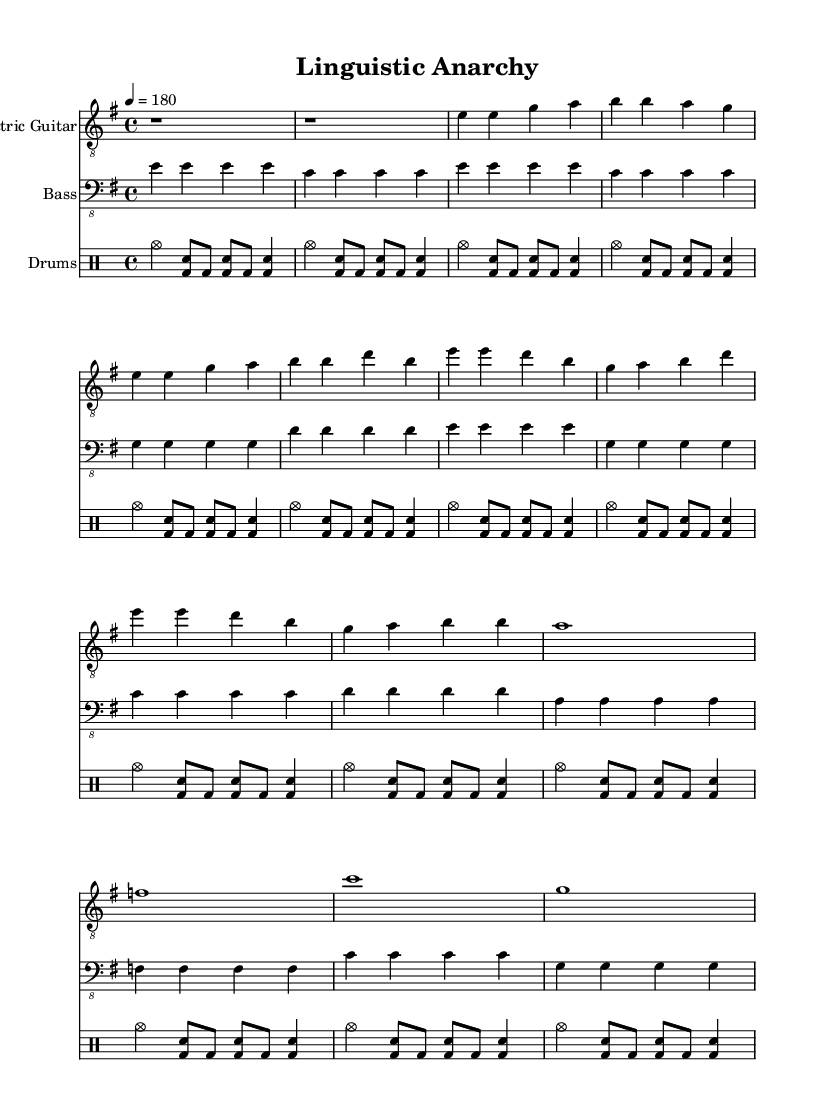What is the key signature of this music? The key signature is E minor, which has one sharp (F#).
Answer: E minor What is the time signature of the music? The time signature is 4/4, indicating four beats per measure.
Answer: 4/4 What is the tempo marking of the piece? The tempo marking is quarter note equals 180 beats per minute.
Answer: 180 How many measures are in the bridge section? The bridge section contains four measures, as indicated by the notations and spacing.
Answer: 4 What instrument is primarily driving the rhythm in this piece? The drums are primarily driving the rhythm, indicated by the use of the drummode and consistent patterns.
Answer: Drums In which section do you first encounter a full chord on a downbeat? The first full chord on a downbeat is encountered in the bridge section, specifically on the first beat of each measure.
Answer: Bridge What repetitive structure is notable in the verse and chorus sections? Both the verse and chorus sections have a repetitive structure with similar rhythmic patterns and chord progressions.
Answer: Repetitive structure 